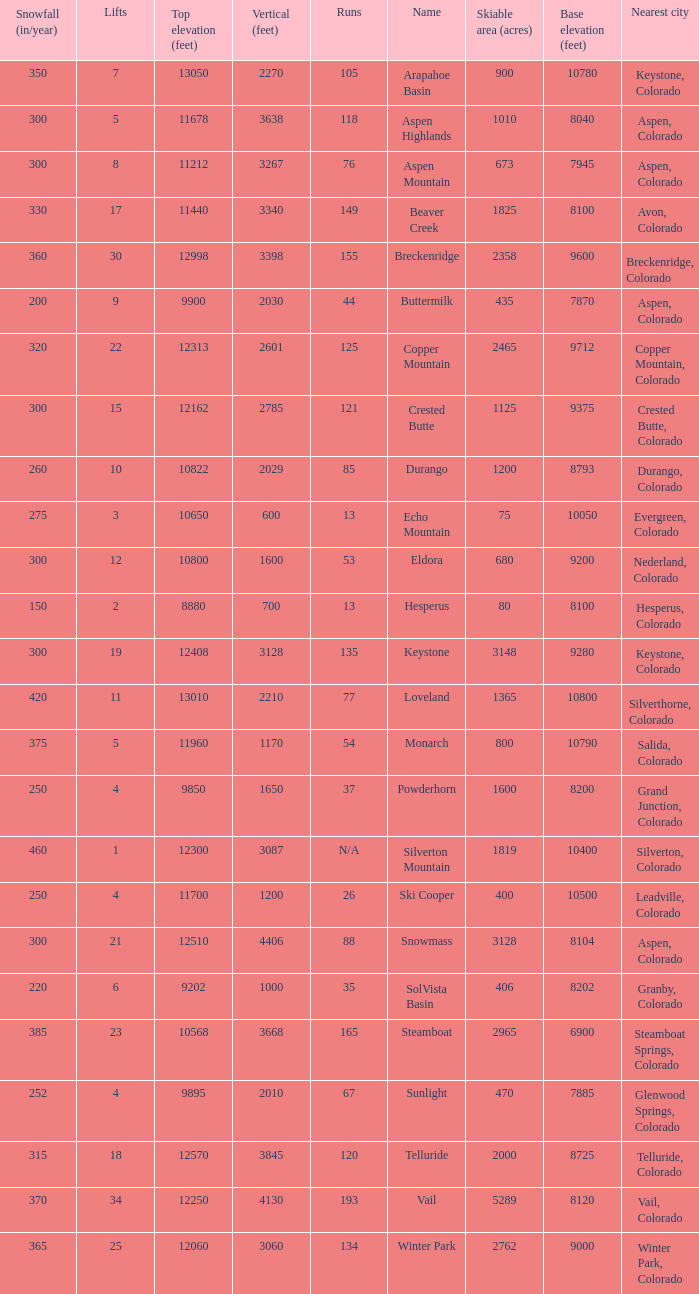What is the snowfall for ski resort Snowmass? 300.0. 